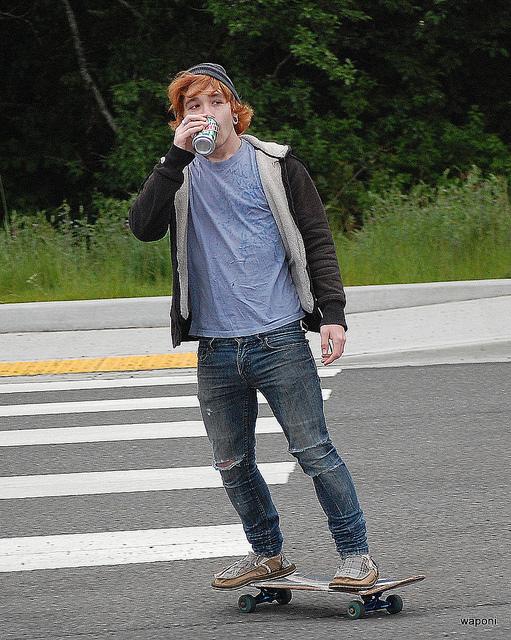Is the skateboard new?
Be succinct. No. Is the man wearing a helmet?
Keep it brief. No. What color is the boys hair?
Keep it brief. Red. What is on the person's knees?
Answer briefly. Jeans. Is this man currently in motion?
Short answer required. Yes. Does the boy wear protective gear?
Keep it brief. No. What is the guy holding in his hand?
Write a very short answer. Can. What type of trendy jeans is the boy wearing?
Give a very brief answer. Skinny. 